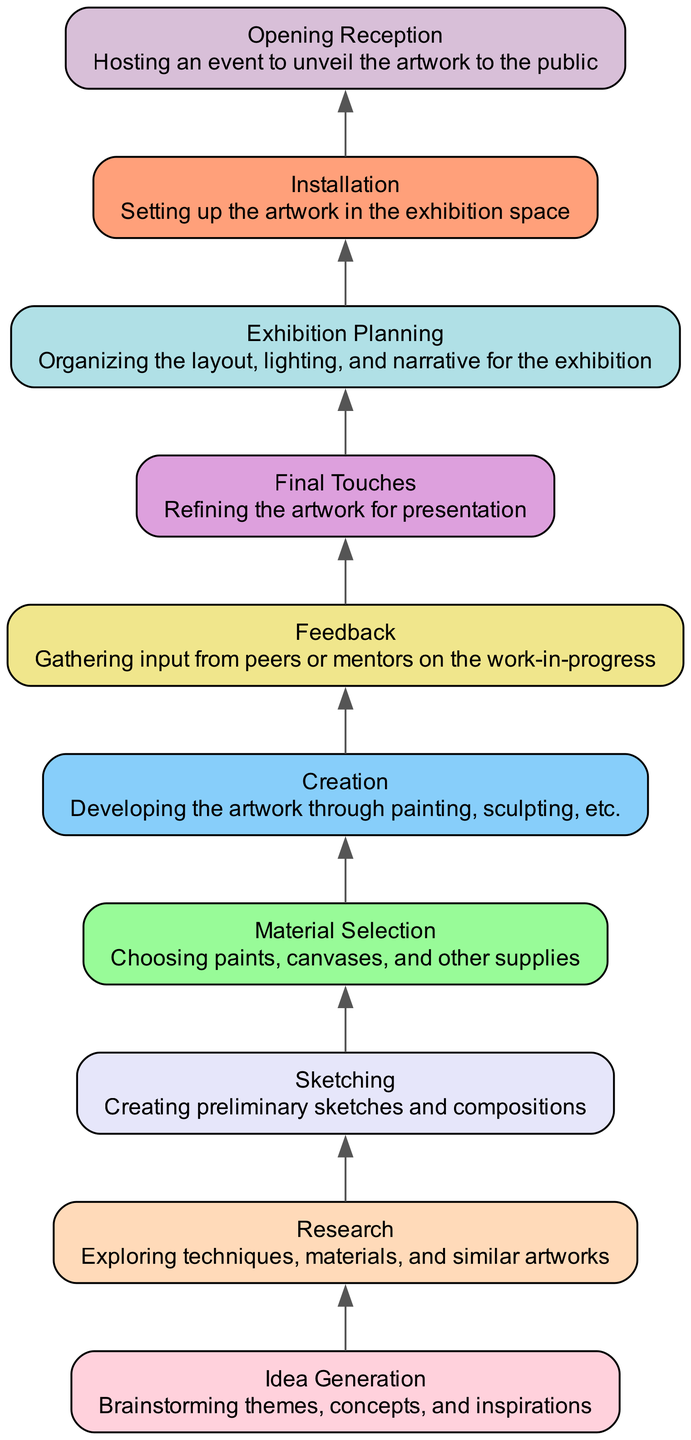What is the first stage in the diagram? The diagram lists the stages in a bottom-up manner, starting from the bottom. The first stage is "Idea Generation," as it appears at the base of the flow.
Answer: Idea Generation How many total stages are represented in the diagram? By counting each stage listed in the diagram, we find a total of 10 individual stages.
Answer: 10 Which stage comes directly after "Creation"? The flow of the diagram indicates that "Feedback" follows sequentially after "Creation," as it is directly connected in the order of stages.
Answer: Feedback What is included in the "Research" stage description? The description for "Research" explicitly states "Exploring techniques, materials, and similar artworks," providing clear information about this stage’s focus.
Answer: Exploring techniques, materials, and similar artworks Which stage involves "Hosting an event to unveil the artwork to the public"? The final stage listed in the diagram is "Opening Reception," which is described as hosting an event to unveil the artwork, making it the answer sought.
Answer: Opening Reception How many stages are there between "Material Selection" and "Installation"? To find the number of stages between these two, we can visually track the flow from "Material Selection" up to "Installation," which covers three stages: "Creation," "Feedback," and "Final Touches."
Answer: 3 What stage immediately precedes "Exhibition Planning"? By examining the flow of the diagram, we note that "Final Touches" occurs just before "Exhibition Planning," highlighting the order of completion for the project stages.
Answer: Final Touches Which two stages are directly connected without any intermediate stages? The stages "Creation" and "Feedback" are connected directly, as no other stages appear between them in the sequence, demonstrating a sequential relationship in the process.
Answer: Creation and Feedback What is the function of the "Installation" stage in the project timeline? The "Installation" stage is defined by the description "Setting up the artwork in the exhibition space," indicating its role in the project timeline.
Answer: Setting up the artwork in the exhibition space 